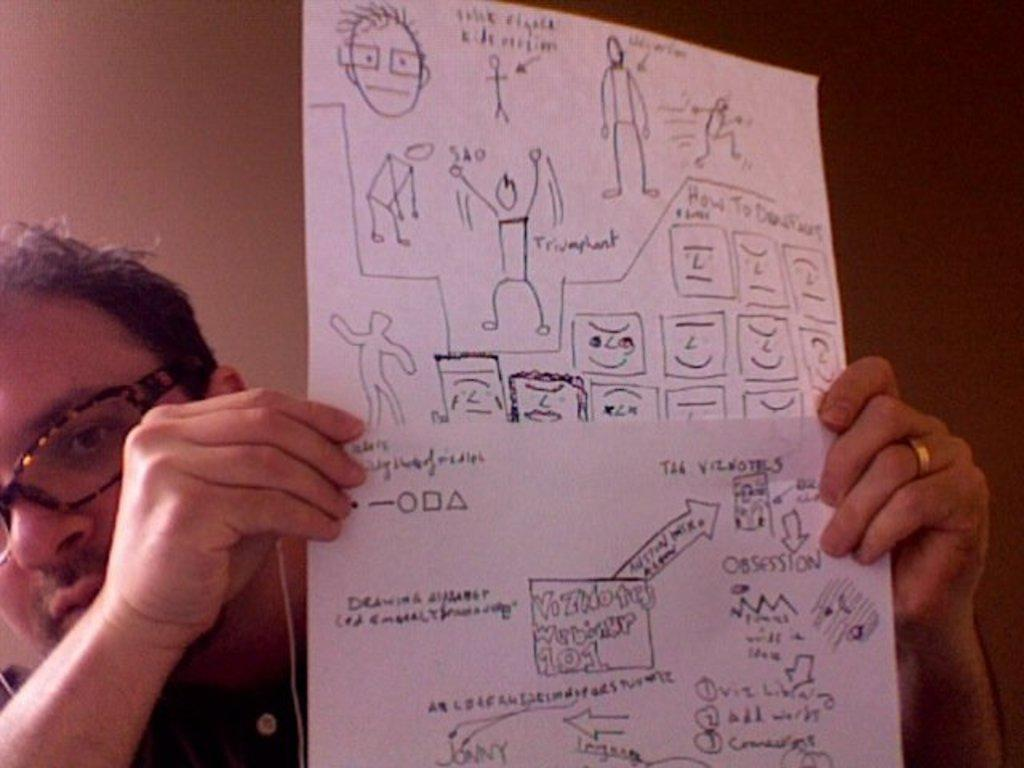Who is present in the image? There is a man in the image. What is the man holding in the image? The man is holding a paper. What can be found on the paper that the man is holding? The paper contains pictures of people and has text on it. What can be seen in the background of the image? There is a wall in the background of the image. What type of action is the man regretting in the image? There is no indication in the image that the man is regretting any action. What does the man's nose look like in the image? The man's nose is not the focus of the image, and no specific details about it are provided. 